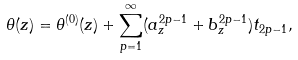<formula> <loc_0><loc_0><loc_500><loc_500>\theta ( z ) = \theta ^ { ( 0 ) } ( z ) + \sum _ { p = 1 } ^ { \infty } ( a _ { z } ^ { 2 p - 1 } + b _ { z } ^ { 2 p - 1 } ) t _ { 2 p - 1 } ,</formula> 